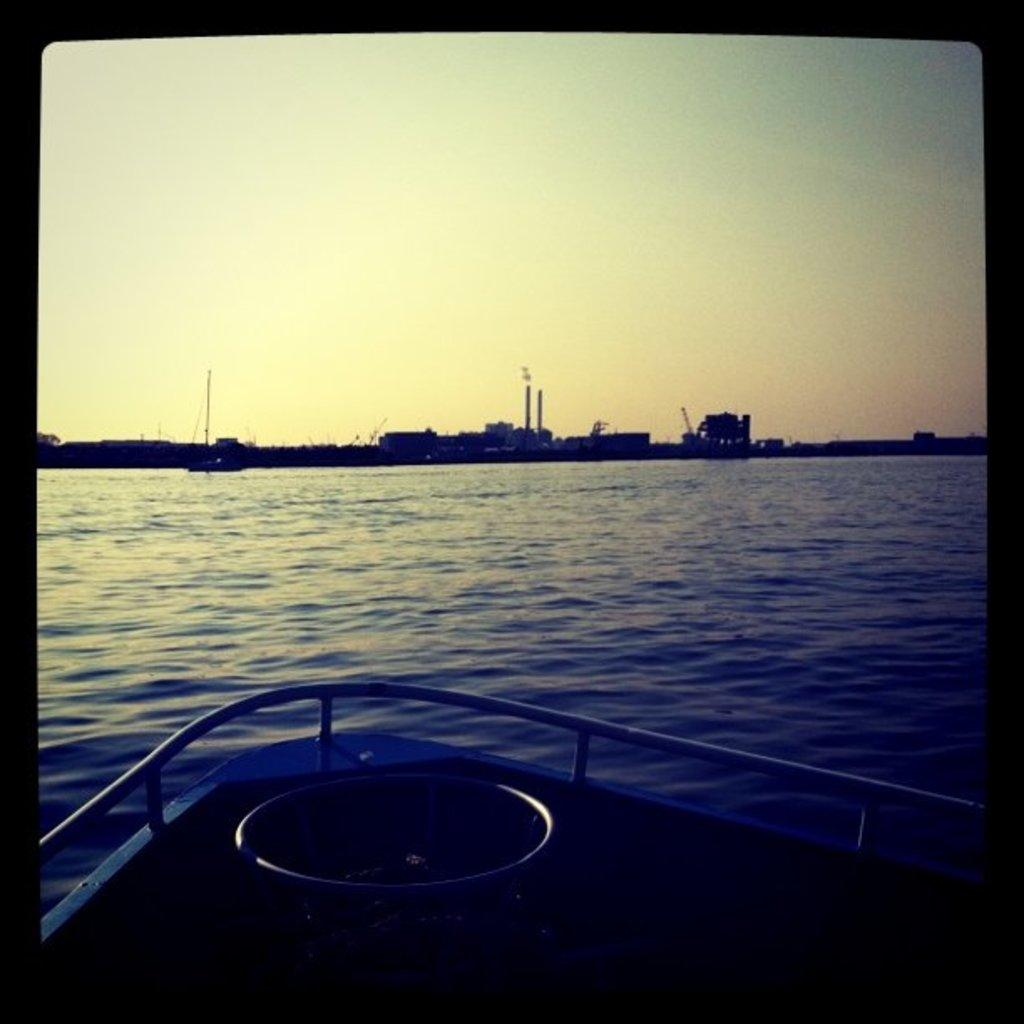What is the vantage point of the image? The image is taken from a boat. What can be seen in the water in the image? There is water visible in the image. What type of structures are present in the image? There are buildings in the image. What is visible in the background of the image? The sky is visible in the background of the image. Where is the cactus located in the image? There is no cactus present in the image. How many girls can be seen playing in the park in the image? There is no park or girls present in the image. 